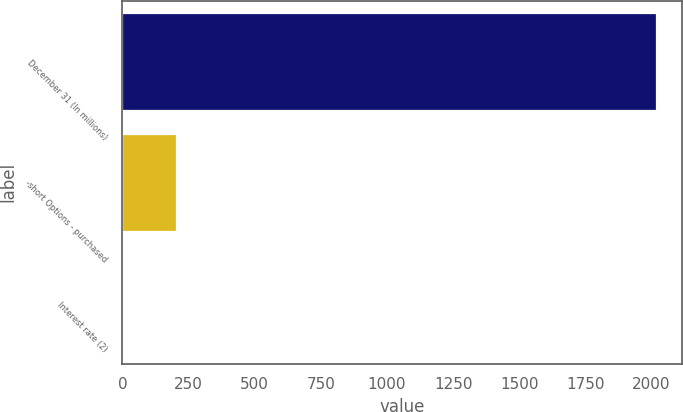Convert chart to OTSL. <chart><loc_0><loc_0><loc_500><loc_500><bar_chart><fcel>December 31 (In millions)<fcel>-short Options - purchased<fcel>Interest rate (2)<nl><fcel>2016<fcel>202.5<fcel>1<nl></chart> 